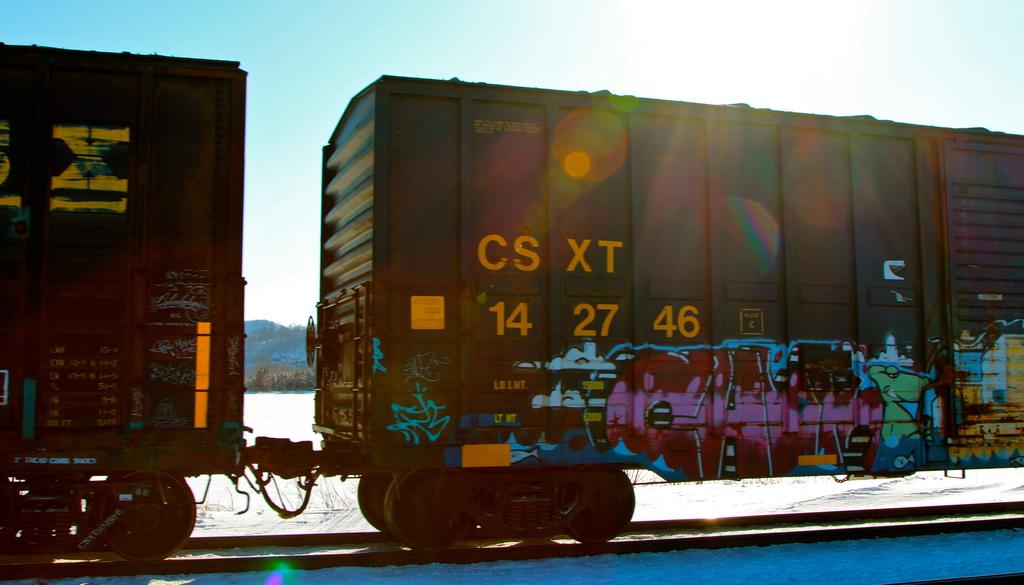What is the main subject in the foreground of the image? There is a train in the foreground of the image. What can be seen in the background of the image? Sky is visible in the background of the image. What type of plantation can be seen in the image? There is no plantation present in the image; it features a train in the foreground and sky in the background. 